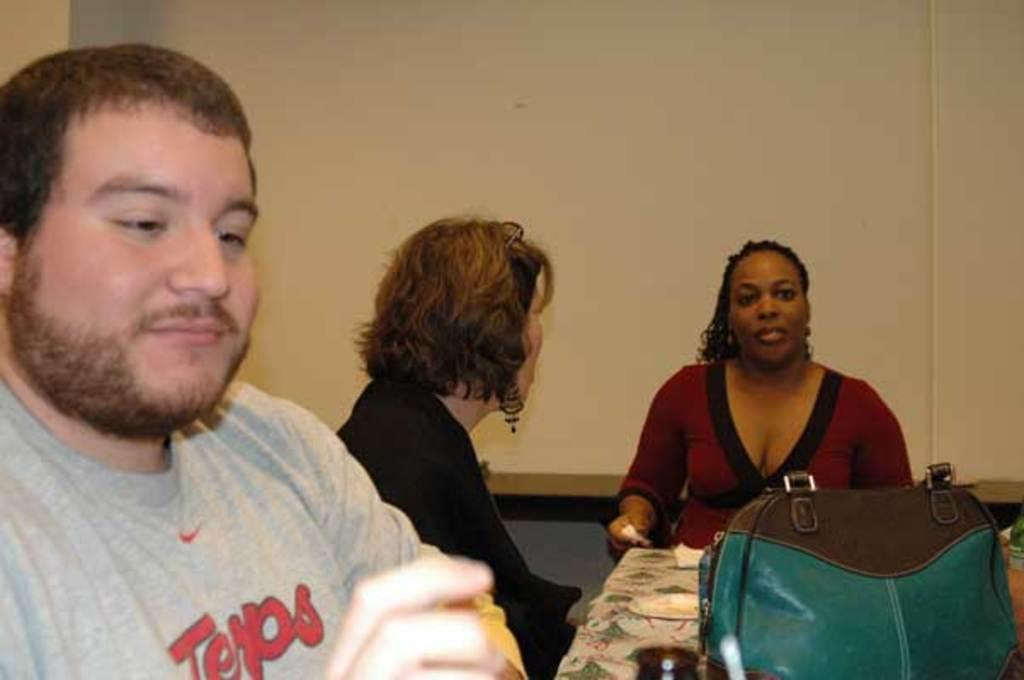Please provide a concise description of this image. On the left side of the image there is a man sitting. There are two women sitting on the chairs near the table. This is the blue color leather bag placed on the top of the table. On the background there is a wall. 